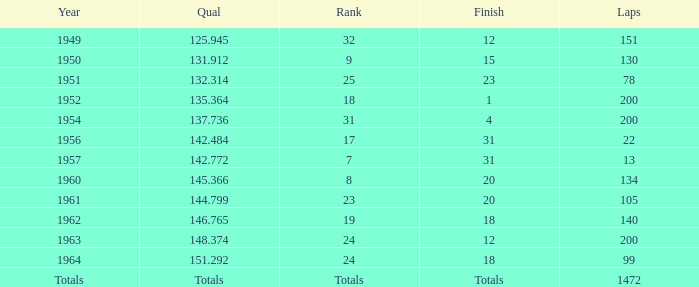Name the year for laps of 200 and rank of 24 1963.0. 